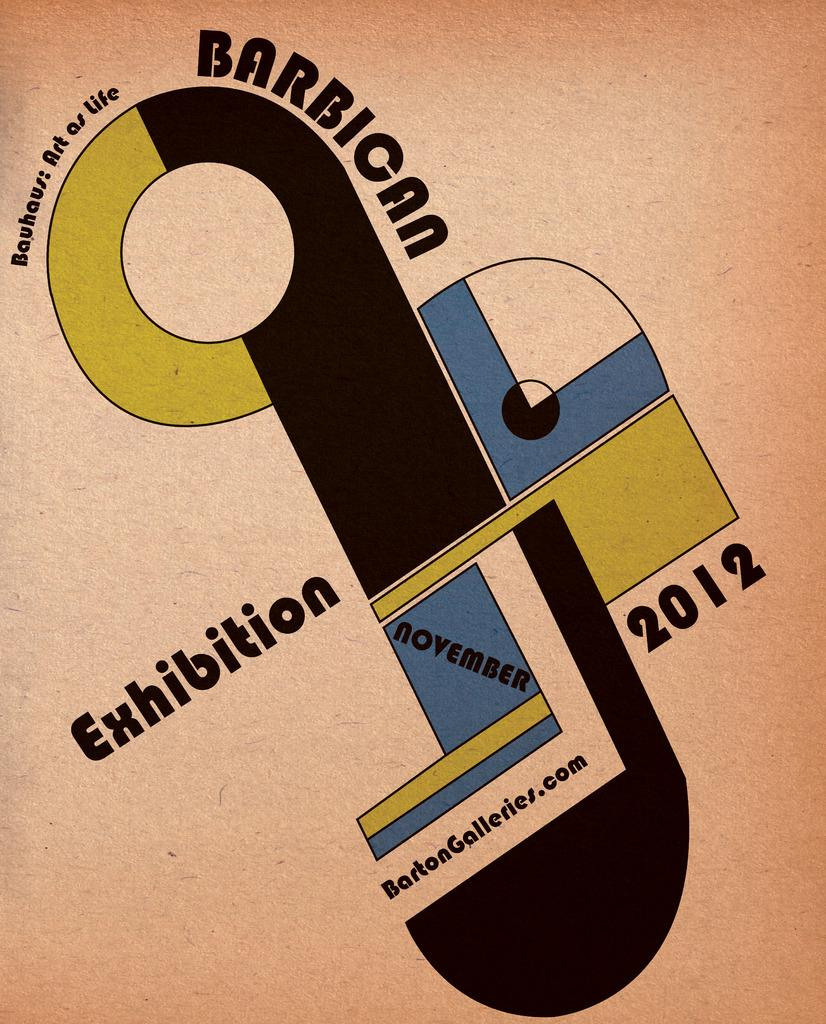<image>
Summarize the visual content of the image. A pocter for the Barbican Exhibition that was held November 2012. 